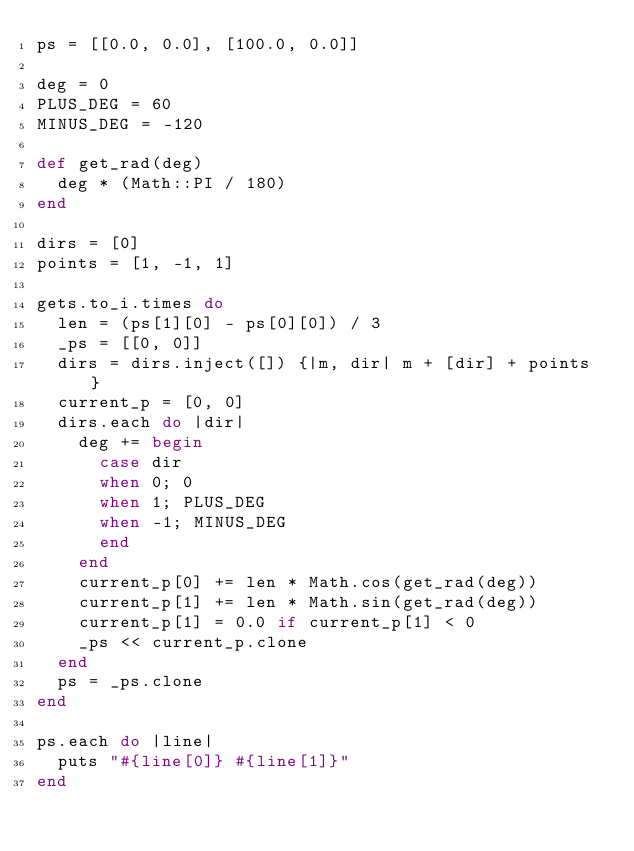Convert code to text. <code><loc_0><loc_0><loc_500><loc_500><_Ruby_>ps = [[0.0, 0.0], [100.0, 0.0]]

deg = 0
PLUS_DEG = 60
MINUS_DEG = -120

def get_rad(deg)
  deg * (Math::PI / 180)
end

dirs = [0]
points = [1, -1, 1]

gets.to_i.times do
  len = (ps[1][0] - ps[0][0]) / 3
  _ps = [[0, 0]]
  dirs = dirs.inject([]) {|m, dir| m + [dir] + points }
  current_p = [0, 0]
  dirs.each do |dir|
    deg += begin
      case dir
      when 0; 0
      when 1; PLUS_DEG
      when -1; MINUS_DEG
      end
    end
    current_p[0] += len * Math.cos(get_rad(deg))
    current_p[1] += len * Math.sin(get_rad(deg))
    current_p[1] = 0.0 if current_p[1] < 0
    _ps << current_p.clone
  end
  ps = _ps.clone
end

ps.each do |line|
  puts "#{line[0]} #{line[1]}"
end</code> 